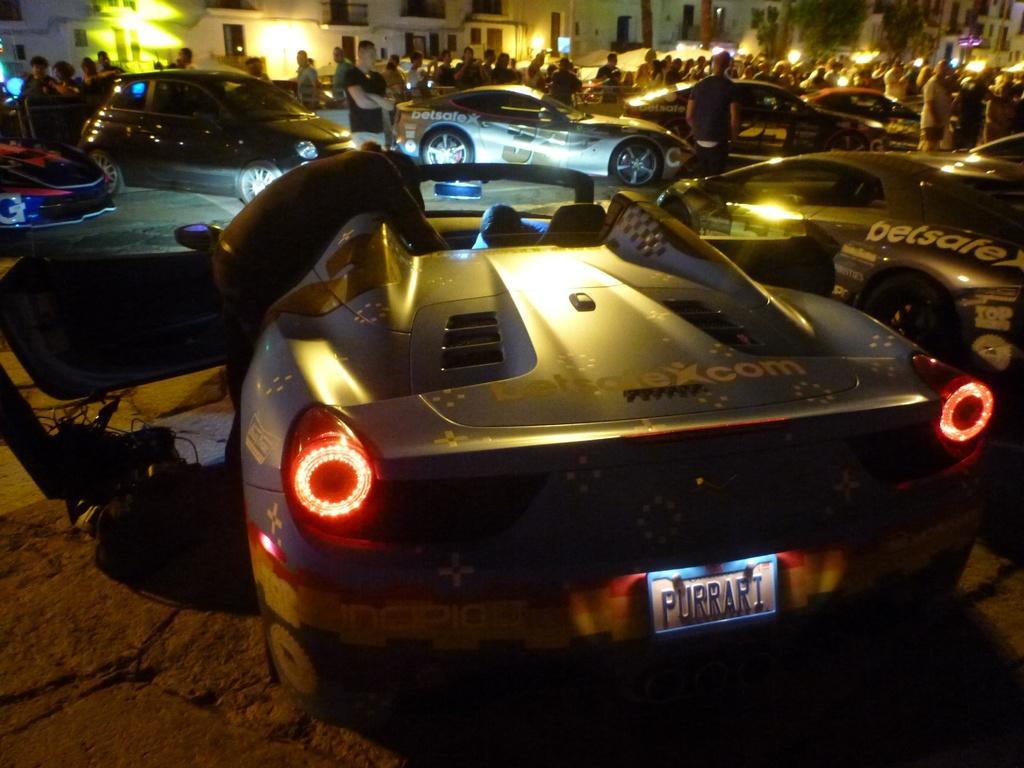Could you give a brief overview of what you see in this image? In this image I can see the vehicles. I can also see some people. In the background, I can see the buildings. 